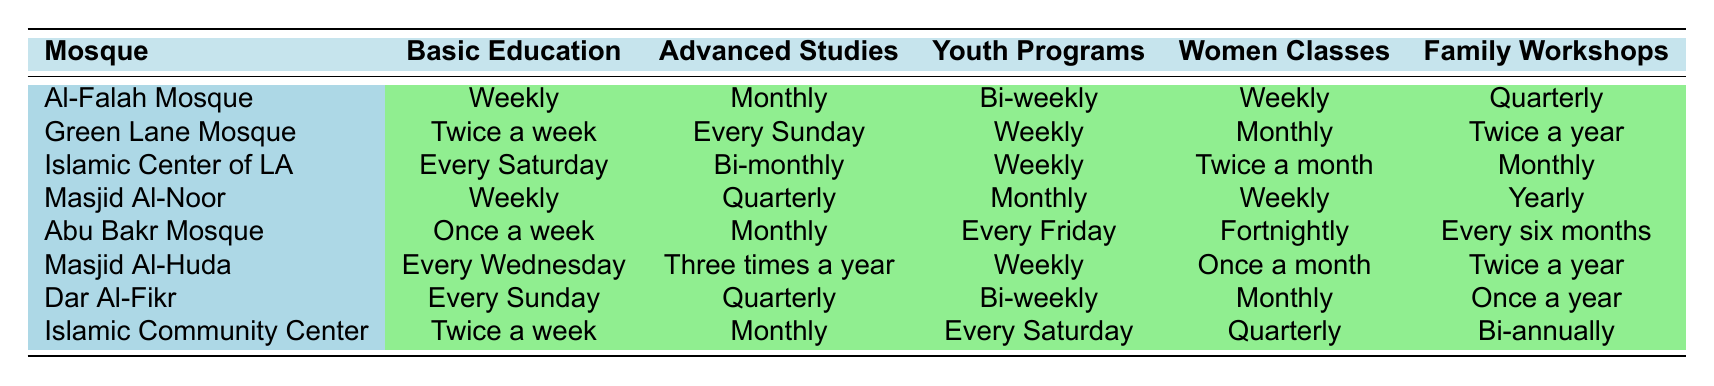What frequency of classes does the Islamic Center of Los Angeles offer for basic education? The table shows that the Islamic Center of Los Angeles offers basic education every Saturday.
Answer: Every Saturday Which mosque offers family workshops most frequently? The Al-Falah Mosque offers family workshops quarterly, Masjid Al-Huda and Islamic Center of Los Angeles offer them monthly, and others offer them less frequently. Thus, Al-Falah Mosque has the highest frequency.
Answer: Al-Falah Mosque How often are women classes conducted at Abu Bakr Mosque? The table shows that Abu Bakr Mosque conducts women classes fortnightly.
Answer: Fortnightly Is youth programming offered weekly at any mosque? Yes, both the Al-Falah Mosque, Green Lane Mosque, Islamic Center of Los Angeles, Masjid Al-Noor, Masjid Al-Huda, and Islamic Community Center offer youth programs weekly.
Answer: Yes What is the difference in frequency of advanced studies between the Islamic Community Center and Masjid Al-Noor? The Islamic Community Center offers advanced studies monthly, while Masjid Al-Noor offers them quarterly. Monthly is four times a year, and quarterly is three times a year, thus the difference is one session a year.
Answer: One session a year Which mosque provides the most overall religious classes (including all categories) in a month? Calculating the frequencies monthly: Al-Falah offers 5 classes (weekly classes count as 4), Islamic Center of LA offers 6 (by roughly accounting twice a month for women classes), and so on. The mosque offering the maximum is Islamic Center of Los Angeles, with approximately 6 classes per month.
Answer: Islamic Center of Los Angeles How often are family workshops offered across all mosques? The family workshop frequencies vary: Al-Falah presents quarterly (3 times a year), Green Lane twice a year (2 times), Islamic Center of LA monthly (12 times), Masjid Al-Noor yearly (1), Abu Bakr every six months (2), Masjid Al-Huda twice a year (2), it totals 22. Average it out: 22/7 mosques gives around 3.14, thus approximately 3 times a year.
Answer: Approximately 3 times a year Which mosque has the least frequency of advanced studies? Analyzing the frequencies: Masjid Al-Noor (quarterly), Masjid Al-Huda (three times a year), and others offer more. Hence Masjid Al-Noor has the least frequency of advanced studies.
Answer: Masjid Al-Noor Do women’s classes occur more frequently than family workshops at the Islamic Community Center? Women’s classes at the Islamic Community Center are quarterly (4 times a year), while family workshops are bi-annually (2 times a year). Thus, they do occur more frequently.
Answer: Yes How frequently do youth programs occur at Masjid Al-Noor? The table indicates that Masjid Al-Noor holds youth programs monthly.
Answer: Monthly Calculate the total number of advanced studies sessions provided by Al-Falah Mosque and Dar Al-Fikr combined in a year. Al-Falah Mosque offers advanced studies monthly (12), and Dar Al-Fikr offers them quarterly (3). Adding these gives 12 + 3 = 15 sessions combined in a year.
Answer: 15 sessions 